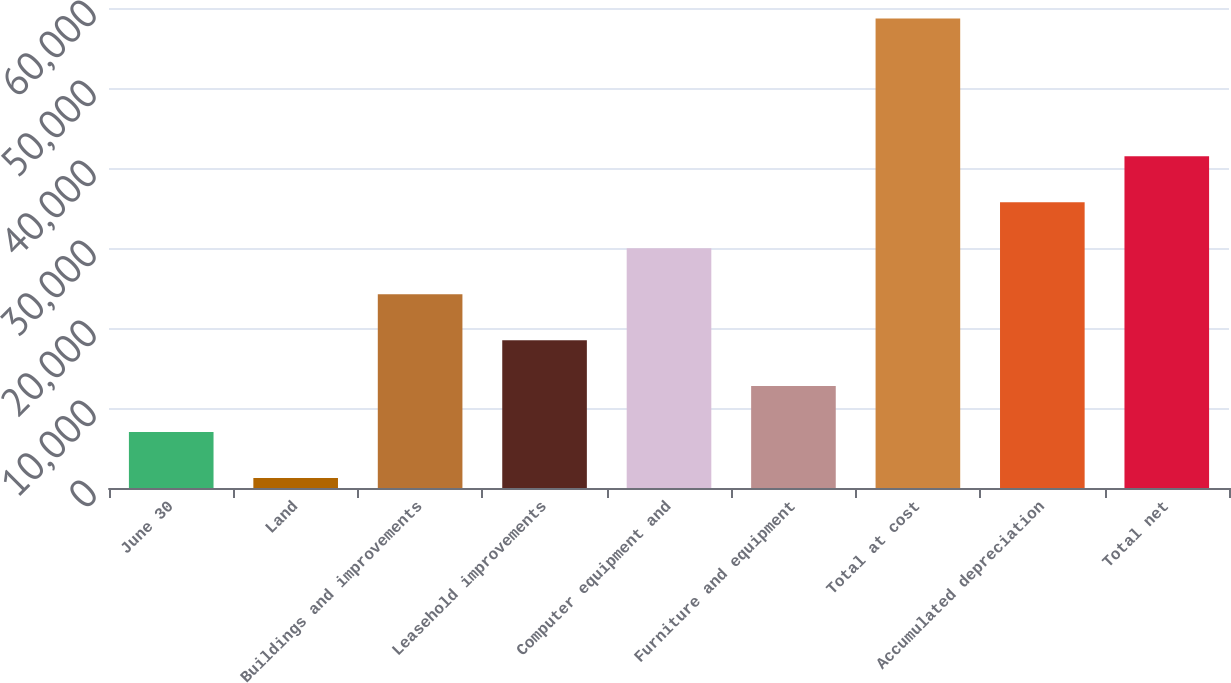Convert chart to OTSL. <chart><loc_0><loc_0><loc_500><loc_500><bar_chart><fcel>June 30<fcel>Land<fcel>Buildings and improvements<fcel>Leasehold improvements<fcel>Computer equipment and<fcel>Furniture and equipment<fcel>Total at cost<fcel>Accumulated depreciation<fcel>Total net<nl><fcel>6996.9<fcel>1254<fcel>24225.6<fcel>18482.7<fcel>29968.5<fcel>12739.8<fcel>58683<fcel>35711.4<fcel>41454.3<nl></chart> 